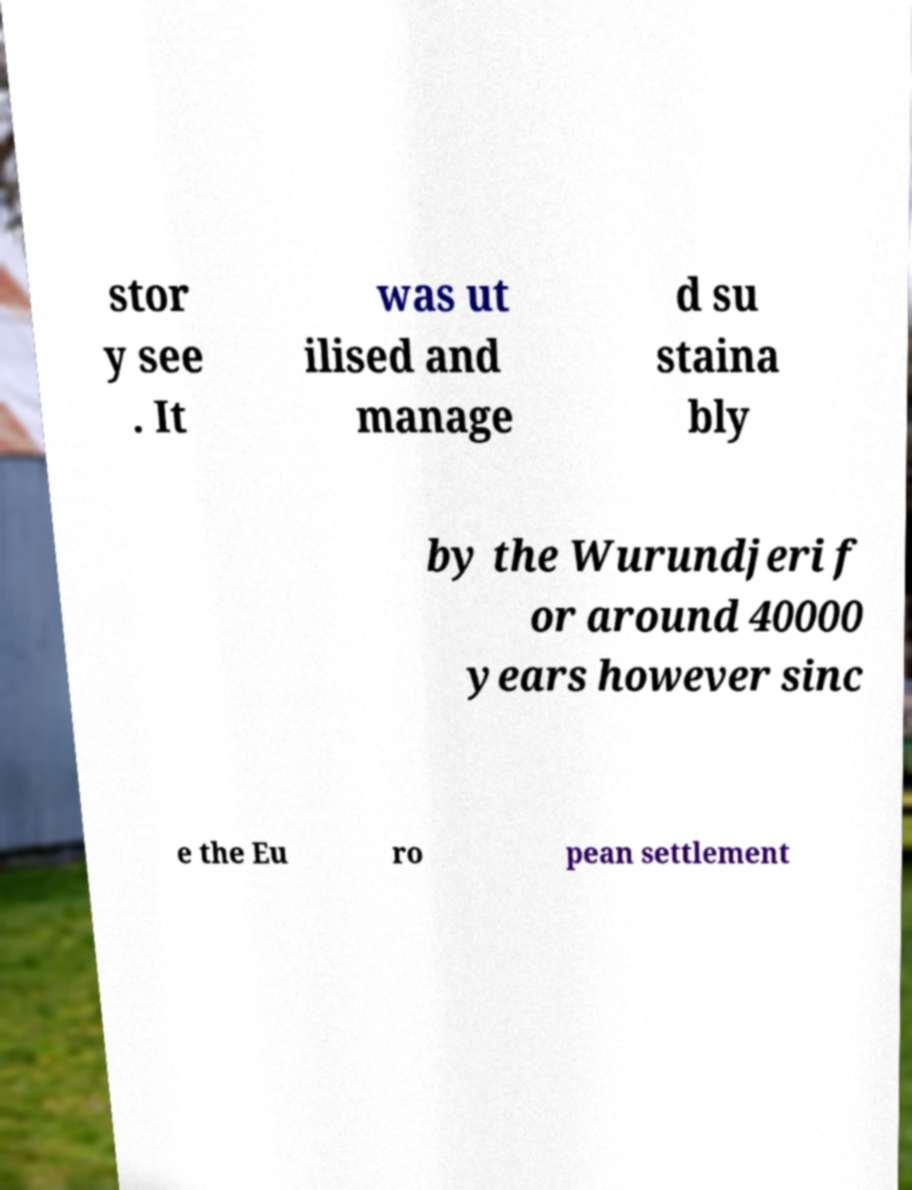What messages or text are displayed in this image? I need them in a readable, typed format. stor y see . It was ut ilised and manage d su staina bly by the Wurundjeri f or around 40000 years however sinc e the Eu ro pean settlement 